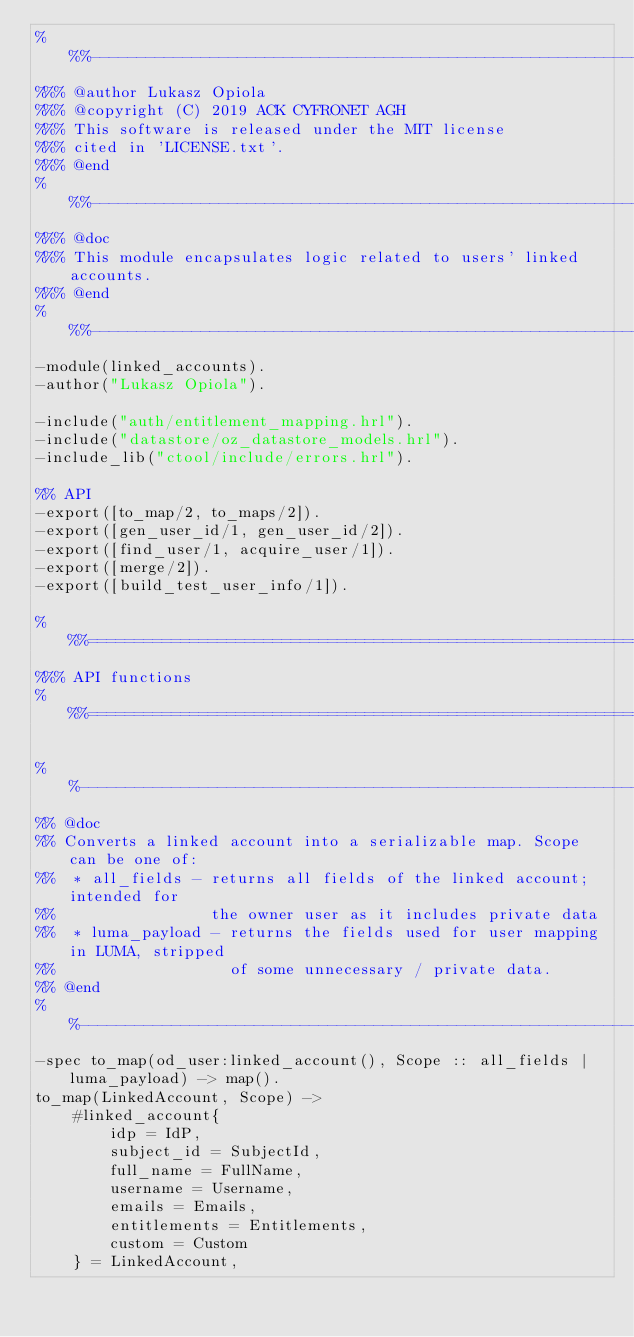<code> <loc_0><loc_0><loc_500><loc_500><_Erlang_>%%%-------------------------------------------------------------------
%%% @author Lukasz Opiola
%%% @copyright (C) 2019 ACK CYFRONET AGH
%%% This software is released under the MIT license
%%% cited in 'LICENSE.txt'.
%%% @end
%%%-------------------------------------------------------------------
%%% @doc
%%% This module encapsulates logic related to users' linked accounts.
%%% @end
%%%-------------------------------------------------------------------
-module(linked_accounts).
-author("Lukasz Opiola").

-include("auth/entitlement_mapping.hrl").
-include("datastore/oz_datastore_models.hrl").
-include_lib("ctool/include/errors.hrl").

%% API
-export([to_map/2, to_maps/2]).
-export([gen_user_id/1, gen_user_id/2]).
-export([find_user/1, acquire_user/1]).
-export([merge/2]).
-export([build_test_user_info/1]).

%%%===================================================================
%%% API functions
%%%===================================================================

%%--------------------------------------------------------------------
%% @doc
%% Converts a linked account into a serializable map. Scope can be one of:
%%  * all_fields - returns all fields of the linked account; intended for
%%                 the owner user as it includes private data
%%  * luma_payload - returns the fields used for user mapping in LUMA, stripped
%%                   of some unnecessary / private data.
%% @end
%%--------------------------------------------------------------------
-spec to_map(od_user:linked_account(), Scope :: all_fields | luma_payload) -> map().
to_map(LinkedAccount, Scope) ->
    #linked_account{
        idp = IdP,
        subject_id = SubjectId,
        full_name = FullName,
        username = Username,
        emails = Emails,
        entitlements = Entitlements,
        custom = Custom
    } = LinkedAccount,
</code> 